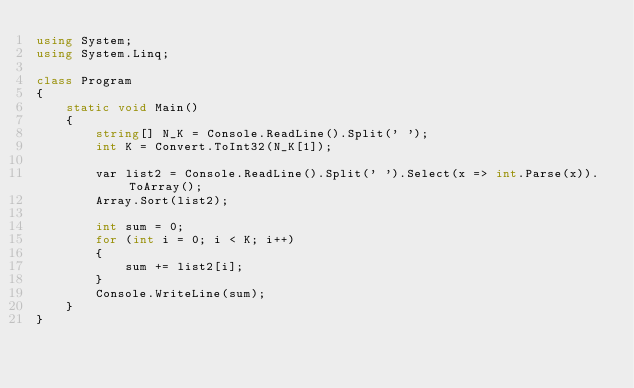<code> <loc_0><loc_0><loc_500><loc_500><_C#_>using System;
using System.Linq;

class Program
{
    static void Main()
    {
        string[] N_K = Console.ReadLine().Split(' ');
        int K = Convert.ToInt32(N_K[1]);

        var list2 = Console.ReadLine().Split(' ').Select(x => int.Parse(x)).ToArray();
        Array.Sort(list2);

        int sum = 0;
        for (int i = 0; i < K; i++)
        {
            sum += list2[i];
        }
        Console.WriteLine(sum);
    }
}</code> 